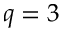Convert formula to latex. <formula><loc_0><loc_0><loc_500><loc_500>q = 3</formula> 